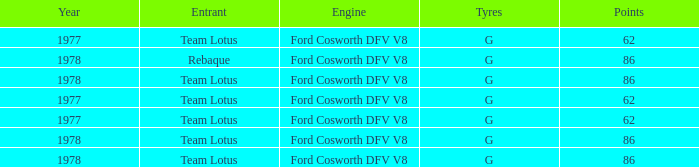What is the Focus that has a Year bigger than 1977? 86, 86, 86, 86. 